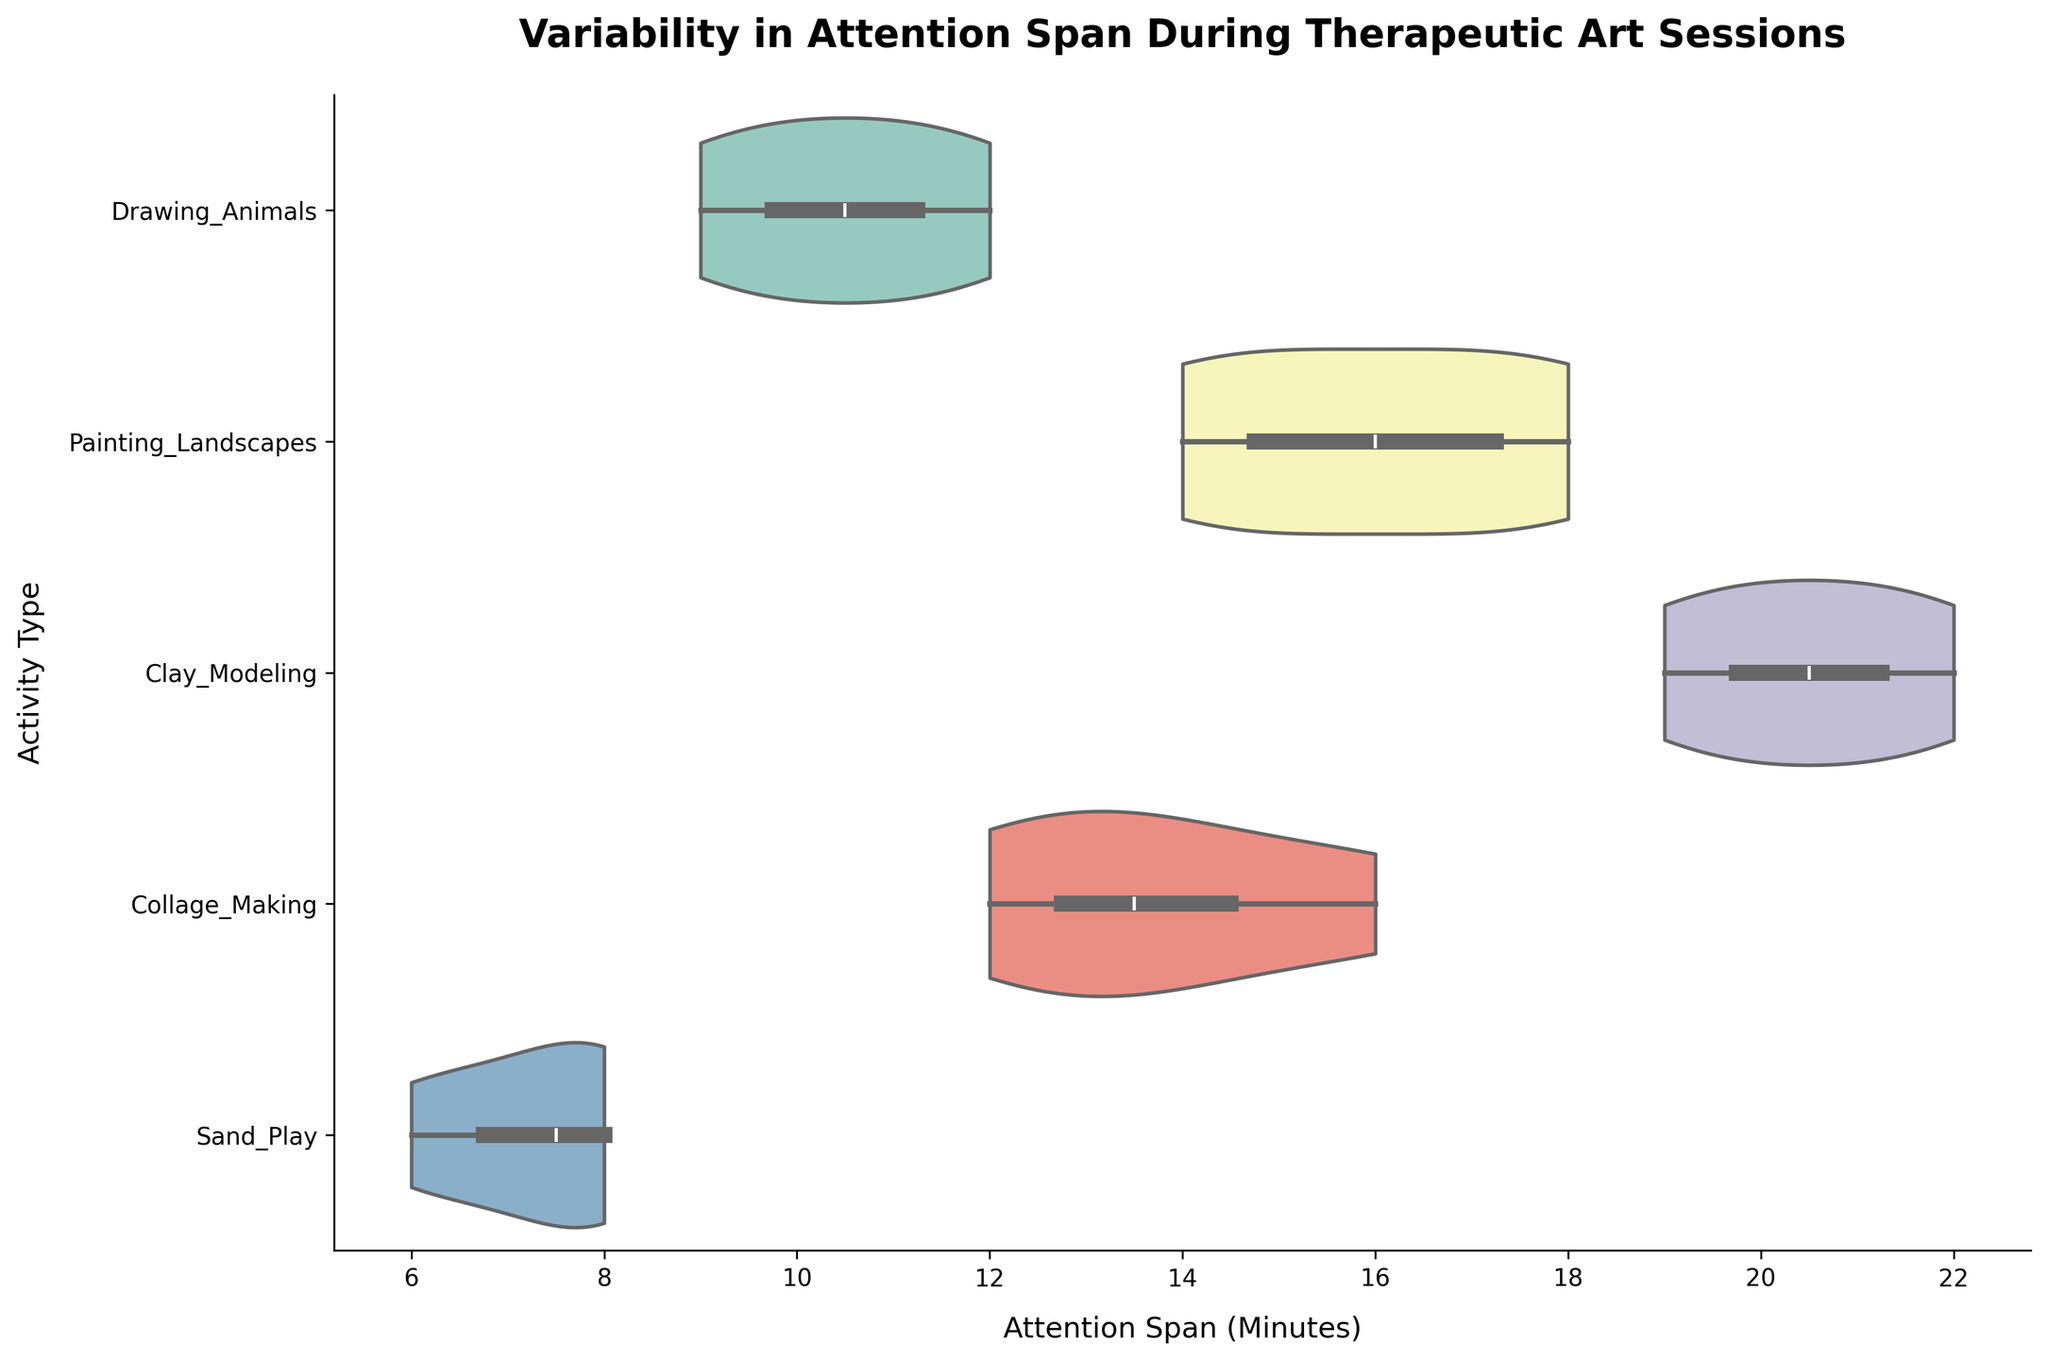What is the title of the figure? The title is usually located at the top of the figure. In this case, it reads "Variability in Attention Span During Therapeutic Art Sessions."
Answer: Variability in Attention Span During Therapeutic Art Sessions What is the average attention span for Drawing Animals? From the violin plot, the box inside the plot represents the interquartile range (IQR), with a line for the median, which can be used to estimate the average. For Drawing Animals, the span ranges roughly from 9 to 12 minutes with a central tendency around 10.5 minutes.
Answer: Approximately 10.5 minutes Which activity shows the highest variability in attention span? The activity with the widest spread in its violin plot shows the highest variability. For this dataset, Clay Modeling shows a wide spread from 19 to 22 minutes, indicating high variability.
Answer: Clay Modeling Between Painting Landscapes and Collage Making, which has a higher median attention span? The median of each plot is the line inside the box. For Painting Landscapes, it's around 16.5, while for Collage Making, it’s around 14.5.
Answer: Painting Landscapes For Sand Play, what is the range of the attention span? The range is the difference between the maximum and minimum values of attention spans in the plot. For Sand Play, it ranges from 6 to 8 minutes.
Answer: 6 to 8 minutes How does the attention span for Sand Play compare to Drawing Animals? Compare the central tendencies (medians) and ranges of the two plots. Sand Play has a smaller range (6 to 8 minutes) and lower median compared to Drawing Animals (9 to 12 minutes).
Answer: Sand Play has a lower attention span Are there any activities where the attention spans overlap? To determine overlap, look for intersections in the ranges of the violin plots. Painting Landscapes and Collage Making overlap slightly as their spans are between 12 and 18 for Painting Landscapes and 12 to 16 for Collage Making.
Answer: Yes, Painting Landscapes and Collage Making Which activity seems to have the most consistent attention span among children? The activity with the narrowest violin plot indicating less spread or variability is Sand Play, with attention spans tightly clustered around 7 to 8 minutes.
Answer: Sand Play 